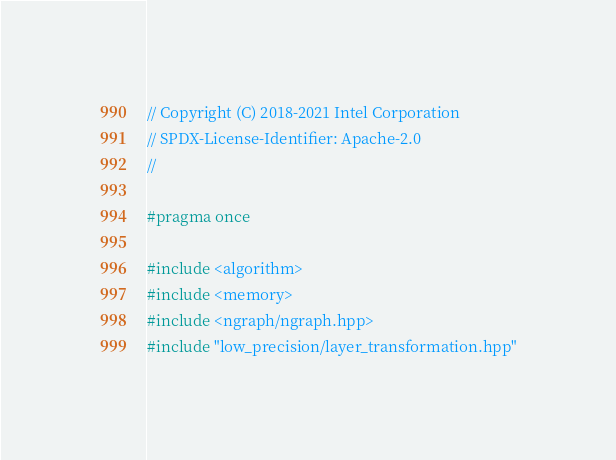Convert code to text. <code><loc_0><loc_0><loc_500><loc_500><_C++_>// Copyright (C) 2018-2021 Intel Corporation
// SPDX-License-Identifier: Apache-2.0
//

#pragma once

#include <algorithm>
#include <memory>
#include <ngraph/ngraph.hpp>
#include "low_precision/layer_transformation.hpp"</code> 